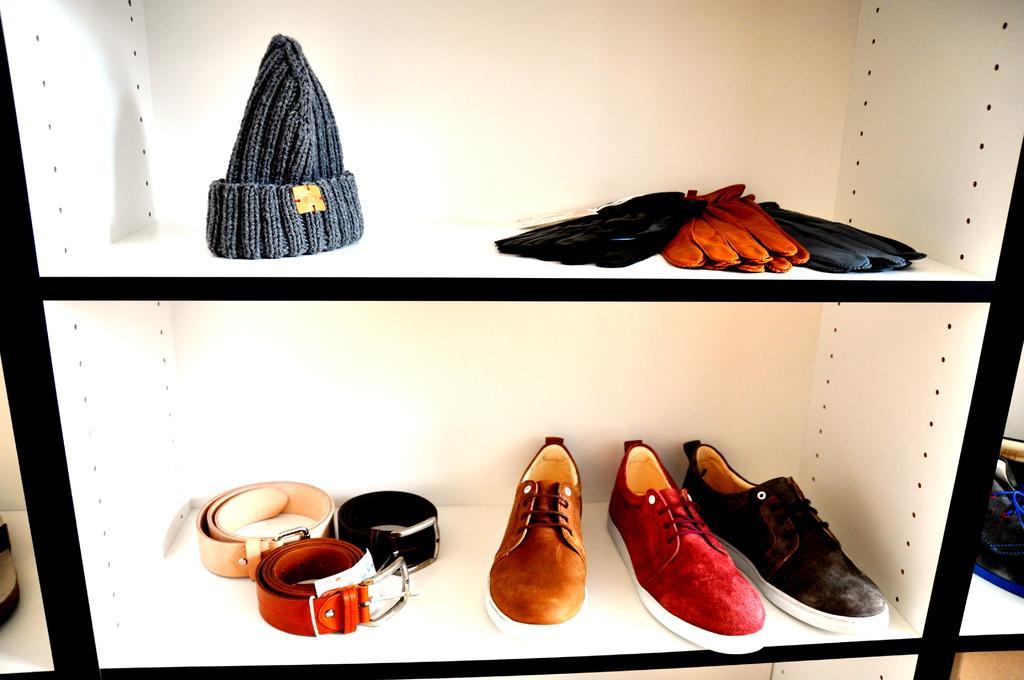Please provide a concise description of this image. This image consists of a rack in which there are shoes, belts, gloves, and a cap. The rack is in white and black color. 